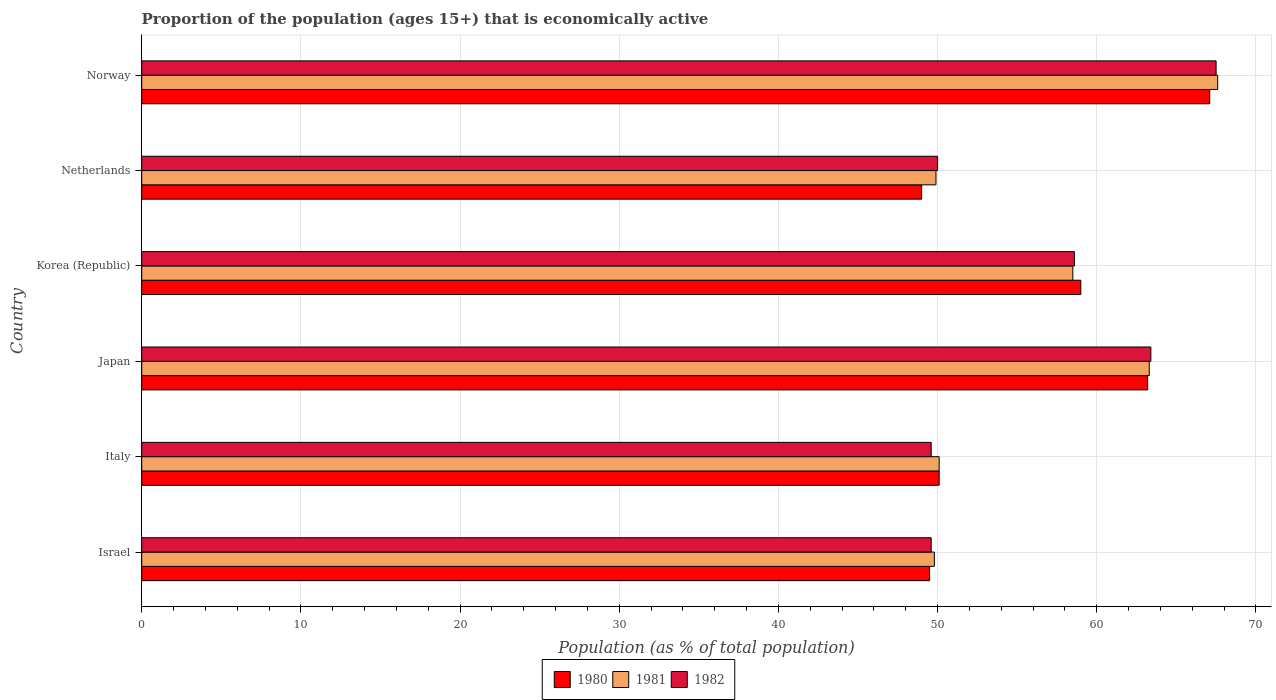How many different coloured bars are there?
Make the answer very short. 3. Are the number of bars per tick equal to the number of legend labels?
Ensure brevity in your answer.  Yes. Are the number of bars on each tick of the Y-axis equal?
Keep it short and to the point. Yes. What is the label of the 4th group of bars from the top?
Ensure brevity in your answer.  Japan. What is the proportion of the population that is economically active in 1981 in Italy?
Provide a succinct answer. 50.1. Across all countries, what is the maximum proportion of the population that is economically active in 1981?
Your answer should be very brief. 67.6. Across all countries, what is the minimum proportion of the population that is economically active in 1980?
Your response must be concise. 49. In which country was the proportion of the population that is economically active in 1982 maximum?
Provide a succinct answer. Norway. What is the total proportion of the population that is economically active in 1981 in the graph?
Your answer should be very brief. 339.2. What is the difference between the proportion of the population that is economically active in 1982 in Japan and that in Norway?
Offer a terse response. -4.1. What is the difference between the proportion of the population that is economically active in 1980 in Japan and the proportion of the population that is economically active in 1982 in Norway?
Keep it short and to the point. -4.3. What is the average proportion of the population that is economically active in 1982 per country?
Your response must be concise. 56.45. In how many countries, is the proportion of the population that is economically active in 1982 greater than 22 %?
Provide a succinct answer. 6. What is the ratio of the proportion of the population that is economically active in 1982 in Italy to that in Norway?
Keep it short and to the point. 0.73. What is the difference between the highest and the second highest proportion of the population that is economically active in 1981?
Make the answer very short. 4.3. What is the difference between the highest and the lowest proportion of the population that is economically active in 1980?
Ensure brevity in your answer.  18.1. In how many countries, is the proportion of the population that is economically active in 1981 greater than the average proportion of the population that is economically active in 1981 taken over all countries?
Make the answer very short. 3. What does the 2nd bar from the bottom in Korea (Republic) represents?
Provide a short and direct response. 1981. How many bars are there?
Offer a very short reply. 18. How many countries are there in the graph?
Your answer should be compact. 6. Are the values on the major ticks of X-axis written in scientific E-notation?
Keep it short and to the point. No. Does the graph contain any zero values?
Provide a short and direct response. No. Does the graph contain grids?
Give a very brief answer. Yes. How many legend labels are there?
Your answer should be compact. 3. How are the legend labels stacked?
Your answer should be compact. Horizontal. What is the title of the graph?
Your answer should be very brief. Proportion of the population (ages 15+) that is economically active. Does "2000" appear as one of the legend labels in the graph?
Keep it short and to the point. No. What is the label or title of the X-axis?
Give a very brief answer. Population (as % of total population). What is the label or title of the Y-axis?
Your answer should be very brief. Country. What is the Population (as % of total population) of 1980 in Israel?
Your response must be concise. 49.5. What is the Population (as % of total population) of 1981 in Israel?
Ensure brevity in your answer.  49.8. What is the Population (as % of total population) in 1982 in Israel?
Provide a succinct answer. 49.6. What is the Population (as % of total population) of 1980 in Italy?
Offer a very short reply. 50.1. What is the Population (as % of total population) in 1981 in Italy?
Your response must be concise. 50.1. What is the Population (as % of total population) in 1982 in Italy?
Provide a short and direct response. 49.6. What is the Population (as % of total population) of 1980 in Japan?
Keep it short and to the point. 63.2. What is the Population (as % of total population) in 1981 in Japan?
Make the answer very short. 63.3. What is the Population (as % of total population) in 1982 in Japan?
Provide a short and direct response. 63.4. What is the Population (as % of total population) in 1980 in Korea (Republic)?
Offer a very short reply. 59. What is the Population (as % of total population) of 1981 in Korea (Republic)?
Offer a very short reply. 58.5. What is the Population (as % of total population) in 1982 in Korea (Republic)?
Your response must be concise. 58.6. What is the Population (as % of total population) in 1980 in Netherlands?
Your answer should be compact. 49. What is the Population (as % of total population) of 1981 in Netherlands?
Give a very brief answer. 49.9. What is the Population (as % of total population) in 1982 in Netherlands?
Your response must be concise. 50. What is the Population (as % of total population) of 1980 in Norway?
Keep it short and to the point. 67.1. What is the Population (as % of total population) of 1981 in Norway?
Offer a very short reply. 67.6. What is the Population (as % of total population) of 1982 in Norway?
Offer a very short reply. 67.5. Across all countries, what is the maximum Population (as % of total population) in 1980?
Offer a terse response. 67.1. Across all countries, what is the maximum Population (as % of total population) in 1981?
Ensure brevity in your answer.  67.6. Across all countries, what is the maximum Population (as % of total population) in 1982?
Provide a short and direct response. 67.5. Across all countries, what is the minimum Population (as % of total population) of 1981?
Keep it short and to the point. 49.8. Across all countries, what is the minimum Population (as % of total population) of 1982?
Provide a succinct answer. 49.6. What is the total Population (as % of total population) in 1980 in the graph?
Keep it short and to the point. 337.9. What is the total Population (as % of total population) of 1981 in the graph?
Make the answer very short. 339.2. What is the total Population (as % of total population) in 1982 in the graph?
Offer a very short reply. 338.7. What is the difference between the Population (as % of total population) of 1980 in Israel and that in Italy?
Your answer should be very brief. -0.6. What is the difference between the Population (as % of total population) of 1982 in Israel and that in Italy?
Offer a terse response. 0. What is the difference between the Population (as % of total population) of 1980 in Israel and that in Japan?
Your response must be concise. -13.7. What is the difference between the Population (as % of total population) of 1981 in Israel and that in Japan?
Offer a terse response. -13.5. What is the difference between the Population (as % of total population) in 1982 in Israel and that in Korea (Republic)?
Your answer should be compact. -9. What is the difference between the Population (as % of total population) of 1980 in Israel and that in Netherlands?
Offer a terse response. 0.5. What is the difference between the Population (as % of total population) in 1982 in Israel and that in Netherlands?
Offer a very short reply. -0.4. What is the difference between the Population (as % of total population) of 1980 in Israel and that in Norway?
Provide a short and direct response. -17.6. What is the difference between the Population (as % of total population) of 1981 in Israel and that in Norway?
Make the answer very short. -17.8. What is the difference between the Population (as % of total population) in 1982 in Israel and that in Norway?
Keep it short and to the point. -17.9. What is the difference between the Population (as % of total population) of 1980 in Italy and that in Japan?
Your answer should be compact. -13.1. What is the difference between the Population (as % of total population) in 1981 in Italy and that in Korea (Republic)?
Ensure brevity in your answer.  -8.4. What is the difference between the Population (as % of total population) of 1981 in Italy and that in Netherlands?
Offer a terse response. 0.2. What is the difference between the Population (as % of total population) of 1980 in Italy and that in Norway?
Offer a very short reply. -17. What is the difference between the Population (as % of total population) in 1981 in Italy and that in Norway?
Keep it short and to the point. -17.5. What is the difference between the Population (as % of total population) of 1982 in Italy and that in Norway?
Provide a short and direct response. -17.9. What is the difference between the Population (as % of total population) of 1981 in Japan and that in Korea (Republic)?
Give a very brief answer. 4.8. What is the difference between the Population (as % of total population) in 1982 in Japan and that in Korea (Republic)?
Your answer should be very brief. 4.8. What is the difference between the Population (as % of total population) in 1980 in Japan and that in Netherlands?
Your answer should be very brief. 14.2. What is the difference between the Population (as % of total population) in 1981 in Japan and that in Netherlands?
Your answer should be very brief. 13.4. What is the difference between the Population (as % of total population) in 1982 in Japan and that in Netherlands?
Ensure brevity in your answer.  13.4. What is the difference between the Population (as % of total population) in 1982 in Japan and that in Norway?
Provide a short and direct response. -4.1. What is the difference between the Population (as % of total population) in 1981 in Korea (Republic) and that in Netherlands?
Offer a very short reply. 8.6. What is the difference between the Population (as % of total population) in 1981 in Korea (Republic) and that in Norway?
Provide a short and direct response. -9.1. What is the difference between the Population (as % of total population) in 1980 in Netherlands and that in Norway?
Your answer should be compact. -18.1. What is the difference between the Population (as % of total population) of 1981 in Netherlands and that in Norway?
Make the answer very short. -17.7. What is the difference between the Population (as % of total population) in 1982 in Netherlands and that in Norway?
Offer a very short reply. -17.5. What is the difference between the Population (as % of total population) of 1981 in Israel and the Population (as % of total population) of 1982 in Italy?
Offer a very short reply. 0.2. What is the difference between the Population (as % of total population) of 1980 in Israel and the Population (as % of total population) of 1982 in Japan?
Keep it short and to the point. -13.9. What is the difference between the Population (as % of total population) in 1980 in Israel and the Population (as % of total population) in 1982 in Korea (Republic)?
Ensure brevity in your answer.  -9.1. What is the difference between the Population (as % of total population) in 1980 in Israel and the Population (as % of total population) in 1981 in Netherlands?
Keep it short and to the point. -0.4. What is the difference between the Population (as % of total population) of 1980 in Israel and the Population (as % of total population) of 1982 in Netherlands?
Ensure brevity in your answer.  -0.5. What is the difference between the Population (as % of total population) of 1980 in Israel and the Population (as % of total population) of 1981 in Norway?
Your answer should be compact. -18.1. What is the difference between the Population (as % of total population) of 1981 in Israel and the Population (as % of total population) of 1982 in Norway?
Ensure brevity in your answer.  -17.7. What is the difference between the Population (as % of total population) in 1980 in Italy and the Population (as % of total population) in 1982 in Japan?
Provide a succinct answer. -13.3. What is the difference between the Population (as % of total population) in 1980 in Italy and the Population (as % of total population) in 1981 in Korea (Republic)?
Provide a short and direct response. -8.4. What is the difference between the Population (as % of total population) in 1981 in Italy and the Population (as % of total population) in 1982 in Korea (Republic)?
Provide a short and direct response. -8.5. What is the difference between the Population (as % of total population) of 1980 in Italy and the Population (as % of total population) of 1981 in Netherlands?
Provide a short and direct response. 0.2. What is the difference between the Population (as % of total population) in 1981 in Italy and the Population (as % of total population) in 1982 in Netherlands?
Provide a succinct answer. 0.1. What is the difference between the Population (as % of total population) in 1980 in Italy and the Population (as % of total population) in 1981 in Norway?
Provide a succinct answer. -17.5. What is the difference between the Population (as % of total population) of 1980 in Italy and the Population (as % of total population) of 1982 in Norway?
Your response must be concise. -17.4. What is the difference between the Population (as % of total population) in 1981 in Italy and the Population (as % of total population) in 1982 in Norway?
Keep it short and to the point. -17.4. What is the difference between the Population (as % of total population) of 1980 in Japan and the Population (as % of total population) of 1981 in Korea (Republic)?
Give a very brief answer. 4.7. What is the difference between the Population (as % of total population) in 1980 in Japan and the Population (as % of total population) in 1982 in Korea (Republic)?
Make the answer very short. 4.6. What is the difference between the Population (as % of total population) of 1981 in Japan and the Population (as % of total population) of 1982 in Korea (Republic)?
Make the answer very short. 4.7. What is the difference between the Population (as % of total population) of 1980 in Japan and the Population (as % of total population) of 1981 in Netherlands?
Ensure brevity in your answer.  13.3. What is the difference between the Population (as % of total population) in 1980 in Japan and the Population (as % of total population) in 1981 in Norway?
Offer a terse response. -4.4. What is the difference between the Population (as % of total population) in 1980 in Japan and the Population (as % of total population) in 1982 in Norway?
Keep it short and to the point. -4.3. What is the difference between the Population (as % of total population) in 1980 in Korea (Republic) and the Population (as % of total population) in 1981 in Norway?
Offer a very short reply. -8.6. What is the difference between the Population (as % of total population) in 1980 in Netherlands and the Population (as % of total population) in 1981 in Norway?
Your answer should be compact. -18.6. What is the difference between the Population (as % of total population) in 1980 in Netherlands and the Population (as % of total population) in 1982 in Norway?
Your answer should be very brief. -18.5. What is the difference between the Population (as % of total population) of 1981 in Netherlands and the Population (as % of total population) of 1982 in Norway?
Offer a very short reply. -17.6. What is the average Population (as % of total population) in 1980 per country?
Make the answer very short. 56.32. What is the average Population (as % of total population) of 1981 per country?
Ensure brevity in your answer.  56.53. What is the average Population (as % of total population) in 1982 per country?
Make the answer very short. 56.45. What is the difference between the Population (as % of total population) in 1980 and Population (as % of total population) in 1982 in Israel?
Give a very brief answer. -0.1. What is the difference between the Population (as % of total population) in 1980 and Population (as % of total population) in 1981 in Italy?
Offer a very short reply. 0. What is the difference between the Population (as % of total population) in 1981 and Population (as % of total population) in 1982 in Italy?
Your answer should be very brief. 0.5. What is the difference between the Population (as % of total population) in 1980 and Population (as % of total population) in 1981 in Japan?
Make the answer very short. -0.1. What is the difference between the Population (as % of total population) in 1981 and Population (as % of total population) in 1982 in Japan?
Provide a short and direct response. -0.1. What is the difference between the Population (as % of total population) in 1981 and Population (as % of total population) in 1982 in Netherlands?
Offer a very short reply. -0.1. What is the difference between the Population (as % of total population) in 1980 and Population (as % of total population) in 1981 in Norway?
Keep it short and to the point. -0.5. What is the difference between the Population (as % of total population) in 1981 and Population (as % of total population) in 1982 in Norway?
Your response must be concise. 0.1. What is the ratio of the Population (as % of total population) of 1980 in Israel to that in Italy?
Your response must be concise. 0.99. What is the ratio of the Population (as % of total population) in 1981 in Israel to that in Italy?
Offer a terse response. 0.99. What is the ratio of the Population (as % of total population) in 1980 in Israel to that in Japan?
Your response must be concise. 0.78. What is the ratio of the Population (as % of total population) of 1981 in Israel to that in Japan?
Your response must be concise. 0.79. What is the ratio of the Population (as % of total population) of 1982 in Israel to that in Japan?
Keep it short and to the point. 0.78. What is the ratio of the Population (as % of total population) in 1980 in Israel to that in Korea (Republic)?
Provide a succinct answer. 0.84. What is the ratio of the Population (as % of total population) in 1981 in Israel to that in Korea (Republic)?
Your answer should be very brief. 0.85. What is the ratio of the Population (as % of total population) of 1982 in Israel to that in Korea (Republic)?
Keep it short and to the point. 0.85. What is the ratio of the Population (as % of total population) in 1980 in Israel to that in Netherlands?
Your response must be concise. 1.01. What is the ratio of the Population (as % of total population) in 1981 in Israel to that in Netherlands?
Ensure brevity in your answer.  1. What is the ratio of the Population (as % of total population) of 1980 in Israel to that in Norway?
Give a very brief answer. 0.74. What is the ratio of the Population (as % of total population) in 1981 in Israel to that in Norway?
Ensure brevity in your answer.  0.74. What is the ratio of the Population (as % of total population) of 1982 in Israel to that in Norway?
Your answer should be compact. 0.73. What is the ratio of the Population (as % of total population) of 1980 in Italy to that in Japan?
Keep it short and to the point. 0.79. What is the ratio of the Population (as % of total population) in 1981 in Italy to that in Japan?
Your response must be concise. 0.79. What is the ratio of the Population (as % of total population) in 1982 in Italy to that in Japan?
Your answer should be compact. 0.78. What is the ratio of the Population (as % of total population) of 1980 in Italy to that in Korea (Republic)?
Keep it short and to the point. 0.85. What is the ratio of the Population (as % of total population) of 1981 in Italy to that in Korea (Republic)?
Make the answer very short. 0.86. What is the ratio of the Population (as % of total population) in 1982 in Italy to that in Korea (Republic)?
Offer a very short reply. 0.85. What is the ratio of the Population (as % of total population) in 1980 in Italy to that in Netherlands?
Your answer should be very brief. 1.02. What is the ratio of the Population (as % of total population) of 1981 in Italy to that in Netherlands?
Ensure brevity in your answer.  1. What is the ratio of the Population (as % of total population) in 1982 in Italy to that in Netherlands?
Provide a succinct answer. 0.99. What is the ratio of the Population (as % of total population) of 1980 in Italy to that in Norway?
Give a very brief answer. 0.75. What is the ratio of the Population (as % of total population) in 1981 in Italy to that in Norway?
Offer a terse response. 0.74. What is the ratio of the Population (as % of total population) of 1982 in Italy to that in Norway?
Offer a very short reply. 0.73. What is the ratio of the Population (as % of total population) of 1980 in Japan to that in Korea (Republic)?
Provide a succinct answer. 1.07. What is the ratio of the Population (as % of total population) in 1981 in Japan to that in Korea (Republic)?
Provide a succinct answer. 1.08. What is the ratio of the Population (as % of total population) in 1982 in Japan to that in Korea (Republic)?
Your answer should be compact. 1.08. What is the ratio of the Population (as % of total population) of 1980 in Japan to that in Netherlands?
Keep it short and to the point. 1.29. What is the ratio of the Population (as % of total population) of 1981 in Japan to that in Netherlands?
Your answer should be very brief. 1.27. What is the ratio of the Population (as % of total population) of 1982 in Japan to that in Netherlands?
Your answer should be compact. 1.27. What is the ratio of the Population (as % of total population) in 1980 in Japan to that in Norway?
Offer a terse response. 0.94. What is the ratio of the Population (as % of total population) of 1981 in Japan to that in Norway?
Your answer should be compact. 0.94. What is the ratio of the Population (as % of total population) of 1982 in Japan to that in Norway?
Keep it short and to the point. 0.94. What is the ratio of the Population (as % of total population) of 1980 in Korea (Republic) to that in Netherlands?
Provide a succinct answer. 1.2. What is the ratio of the Population (as % of total population) of 1981 in Korea (Republic) to that in Netherlands?
Provide a short and direct response. 1.17. What is the ratio of the Population (as % of total population) in 1982 in Korea (Republic) to that in Netherlands?
Ensure brevity in your answer.  1.17. What is the ratio of the Population (as % of total population) in 1980 in Korea (Republic) to that in Norway?
Make the answer very short. 0.88. What is the ratio of the Population (as % of total population) in 1981 in Korea (Republic) to that in Norway?
Provide a succinct answer. 0.87. What is the ratio of the Population (as % of total population) in 1982 in Korea (Republic) to that in Norway?
Offer a very short reply. 0.87. What is the ratio of the Population (as % of total population) in 1980 in Netherlands to that in Norway?
Offer a terse response. 0.73. What is the ratio of the Population (as % of total population) in 1981 in Netherlands to that in Norway?
Offer a very short reply. 0.74. What is the ratio of the Population (as % of total population) in 1982 in Netherlands to that in Norway?
Give a very brief answer. 0.74. What is the difference between the highest and the second highest Population (as % of total population) of 1980?
Give a very brief answer. 3.9. What is the difference between the highest and the second highest Population (as % of total population) of 1981?
Your response must be concise. 4.3. What is the difference between the highest and the second highest Population (as % of total population) in 1982?
Offer a very short reply. 4.1. What is the difference between the highest and the lowest Population (as % of total population) of 1982?
Make the answer very short. 17.9. 